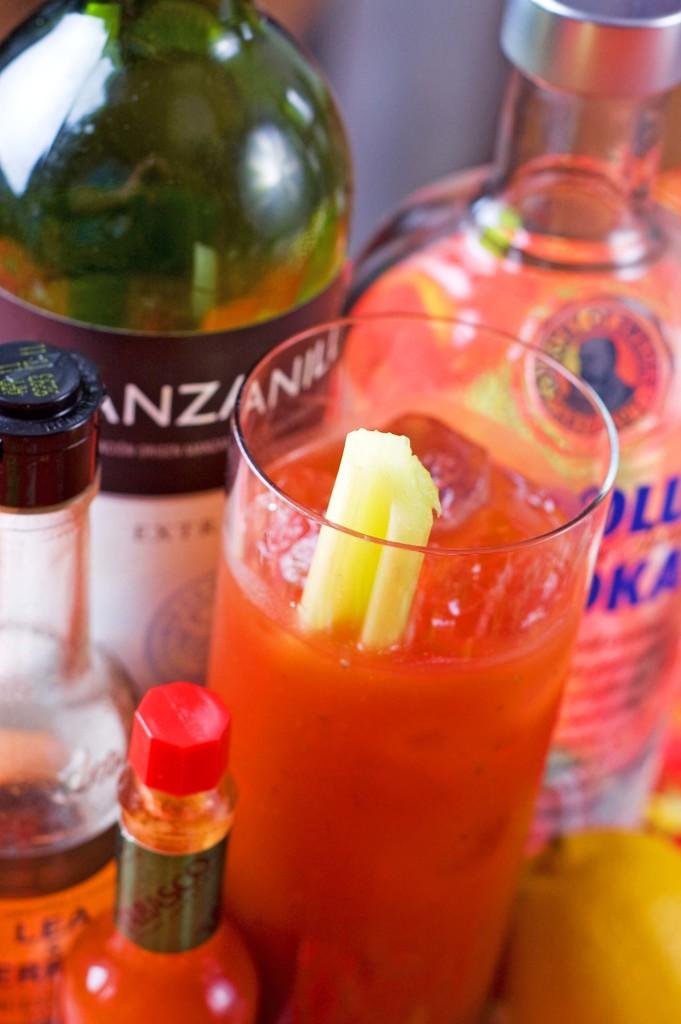How many bottles are visible in the image? There are four bottles in the image. What else can be seen in the image besides the bottles? There is a glass filled with a drink in the image. How much salt is in the glass in the image? There is no salt present in the image; it contains a drink. What type of zipper can be seen on the glass in the image? There is no zipper on the glass in the image; it is a regular drinking glass. 